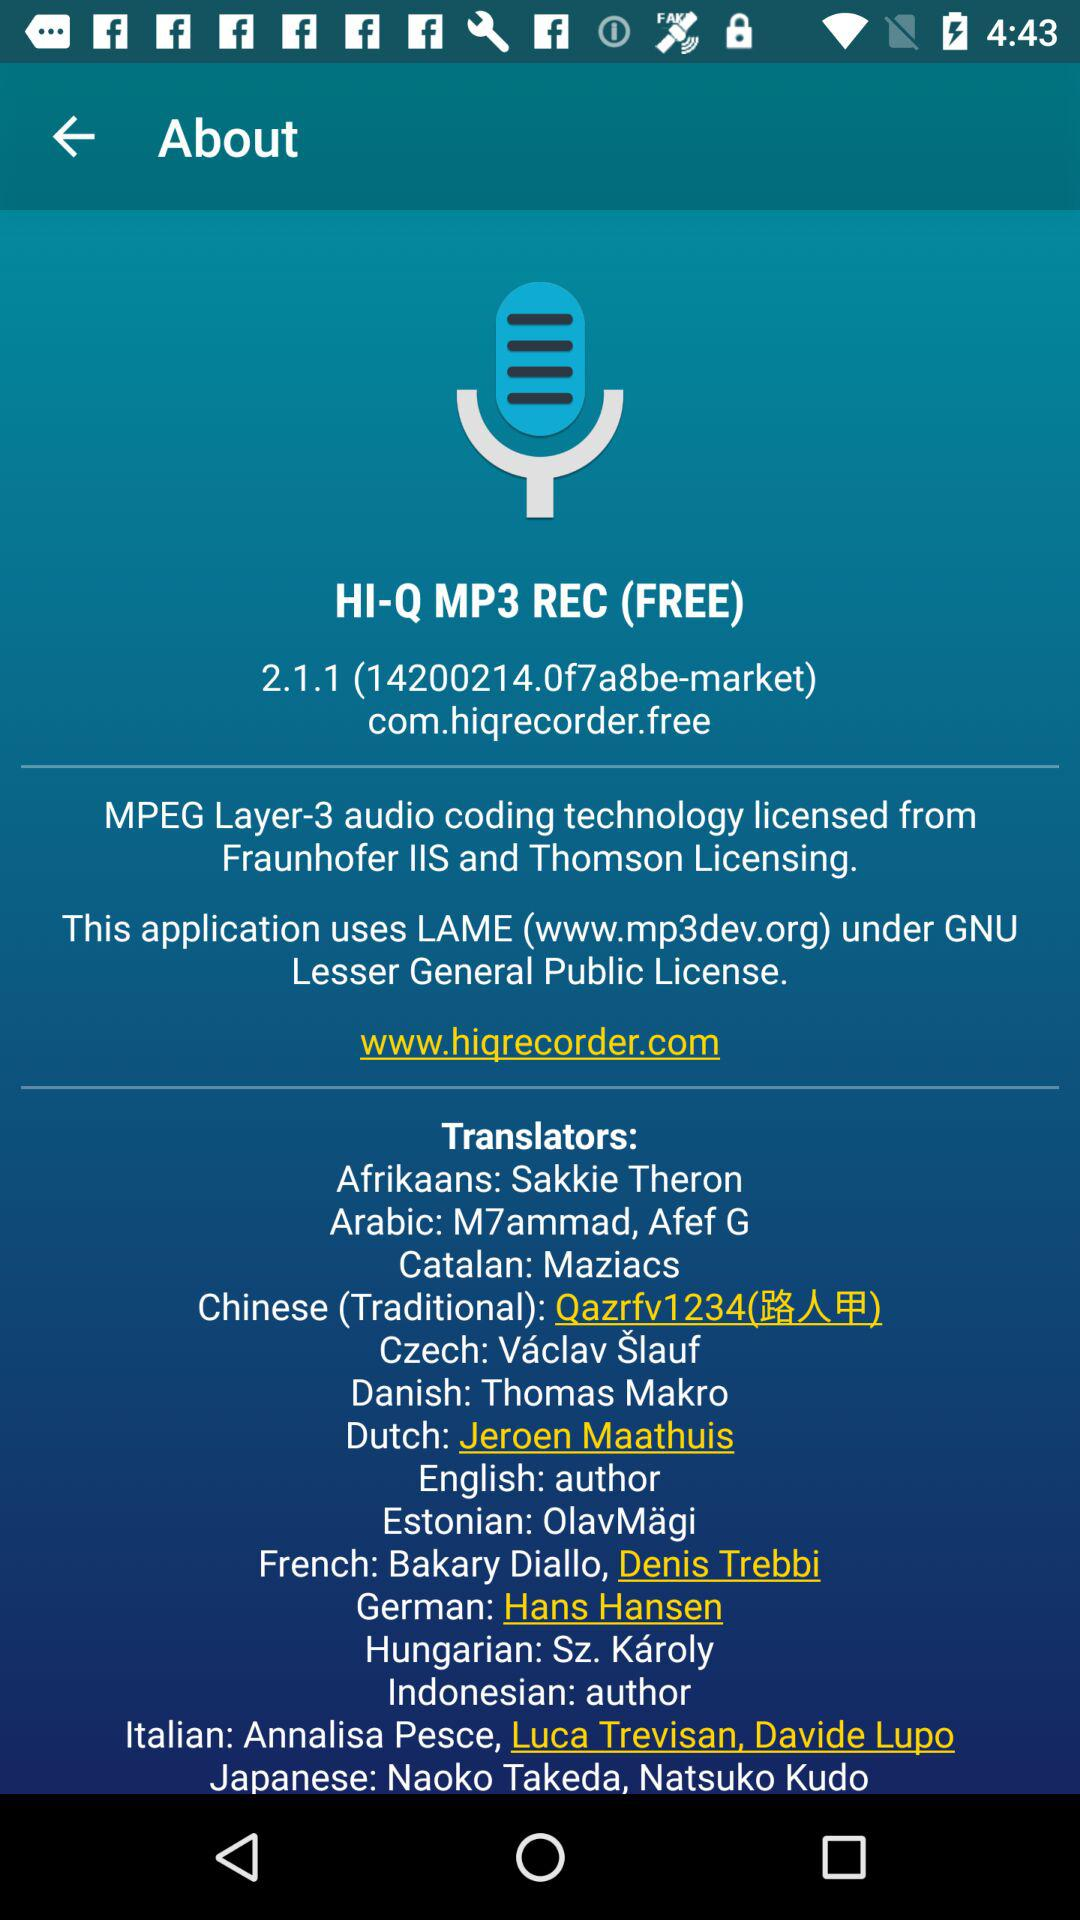What is the version of the application? The version is 2.1.1 (14200214.0f7a8be-market). 